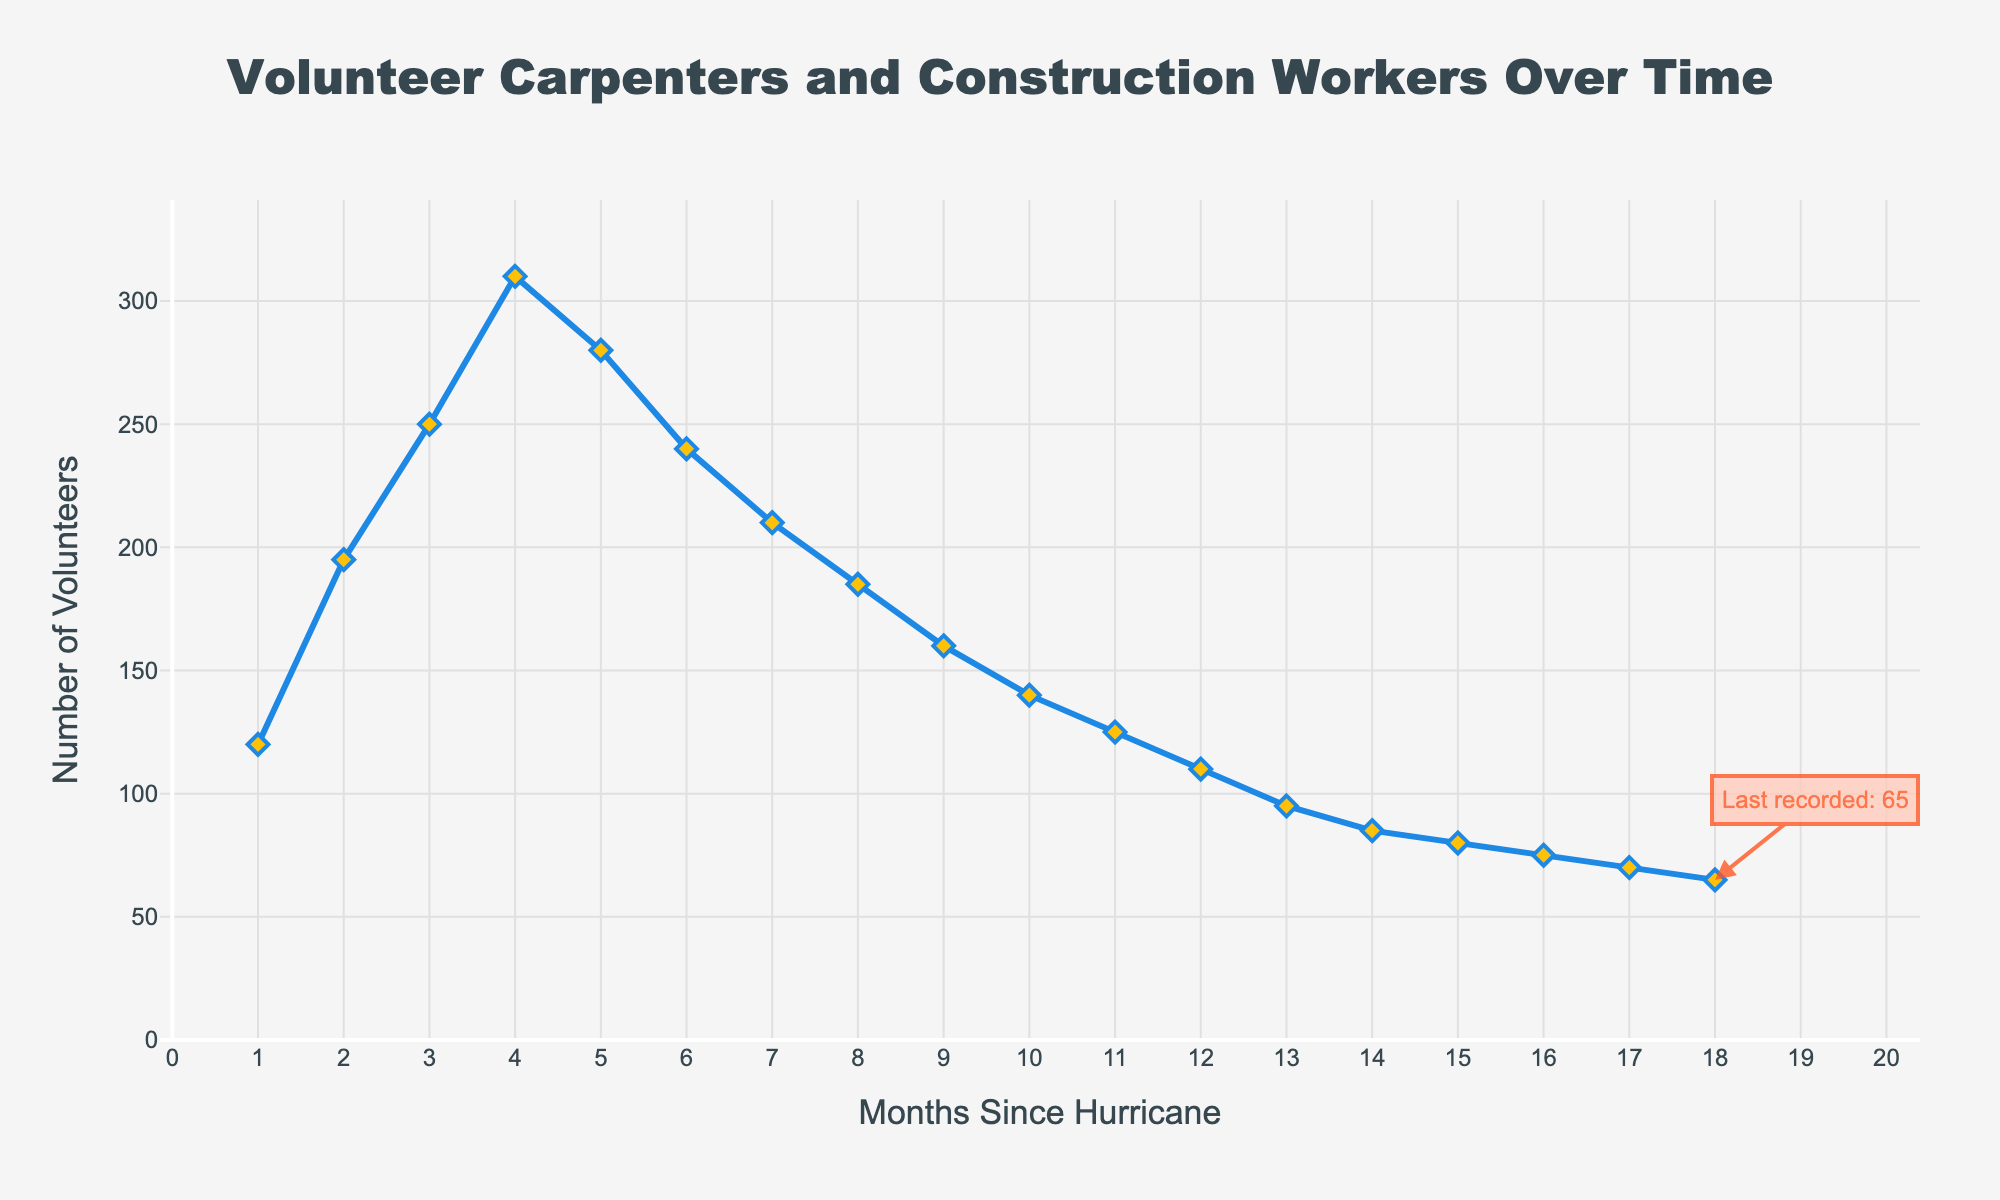How does the number of volunteer carpenters and construction workers change from Month 1 to Month 4? From Month 1 to Month 4, the number of volunteers increases from 120 to 310. This is a steady rise each month.
Answer: It increases What is the highest recorded number of volunteers, and in which month does it occur? The highest number of volunteers is 310, occurring in Month 4. This can be observed as the peak point on the graph.
Answer: 310 in Month 4 By how much does the number of volunteer carpenters and construction workers decrease from Month 4 to Month 10? The number decreases from 310 in Month 4 to 140 in Month 10. The difference is 310 - 140 = 170.
Answer: 170 What is the trend in the number of volunteer carpenters and construction workers over the 18 months? The trend shows that the number of volunteers steadily increases until Month 4, after which it starts to gradually decrease over time until Month 18.
Answer: Increase then decrease Compare the number of volunteers in the first six months with the last six months. The first six months show a growth from 120 to 240, while the last six months show a decline from 85 to 65. This indicates a clear upward trend initially followed by a consistent downward trend.
Answer: First six months: increase; last six months: decrease What is the difference in the number of volunteers between Month 2 and Month 12? The number of volunteers in Month 2 is 195 and in Month 12 is 110. The difference is 195 - 110 = 85.
Answer: 85 How did the number of volunteers change on average per month for the first four months? The total increase over the first four months is 310 - 120 = 190 volunteers. Dividing by the 4 months, the average monthly increase is 190 / 4 = 47.5 volunteers.
Answer: 47.5 per month Is there a month where the number of volunteers remains constant or fluctuates minimally compared to the previous month? The number of volunteers declines gradually and becomes relatively steady around Month 15 to Month 18, decreasing minimally from 80 to 75 to 70 to 65.
Answer: Month 15-18 What is the color of the markers used to represent data points on the line? The markers are represented by diamond shapes with a yellow color and a blue outline.
Answer: Yellow with blue outline What was the rate of change in the number of volunteers between the peaks and valleys of the data? From the peak in Month 4 (310) to the lowest point in Month 18 (65), the rate of change would be calculated as (310 - 65) / (18 - 4) = 245 / 14 ≈ 17.5 volunteers per month on average.
Answer: 17.5 volunteers per month 